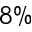<formula> <loc_0><loc_0><loc_500><loc_500>8 \%</formula> 